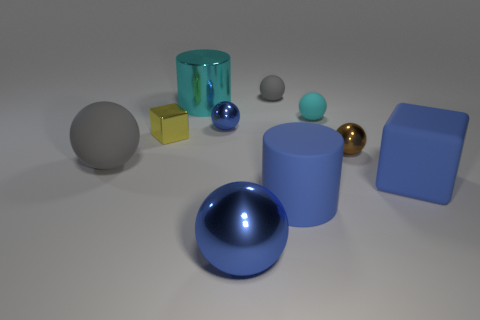The large cube that is the same material as the small gray ball is what color?
Your answer should be compact. Blue. There is a cyan matte object; is its size the same as the gray rubber sphere that is to the right of the tiny blue metal object?
Provide a succinct answer. Yes. What material is the cyan object that is to the left of the ball in front of the block on the right side of the large matte cylinder made of?
Provide a succinct answer. Metal. How many objects are either purple metal spheres or spheres?
Ensure brevity in your answer.  6. There is a large matte thing that is behind the rubber block; is it the same color as the cylinder behind the tiny block?
Keep it short and to the point. No. There is a yellow thing that is the same size as the brown metal thing; what is its shape?
Provide a succinct answer. Cube. What number of objects are big metallic things behind the small block or blue things behind the big matte cylinder?
Keep it short and to the point. 3. Is the number of big blue metallic balls less than the number of blue shiny objects?
Make the answer very short. Yes. There is a blue cylinder that is the same size as the matte block; what material is it?
Give a very brief answer. Rubber. Do the metallic sphere that is in front of the big gray thing and the gray object that is behind the large gray ball have the same size?
Ensure brevity in your answer.  No. 